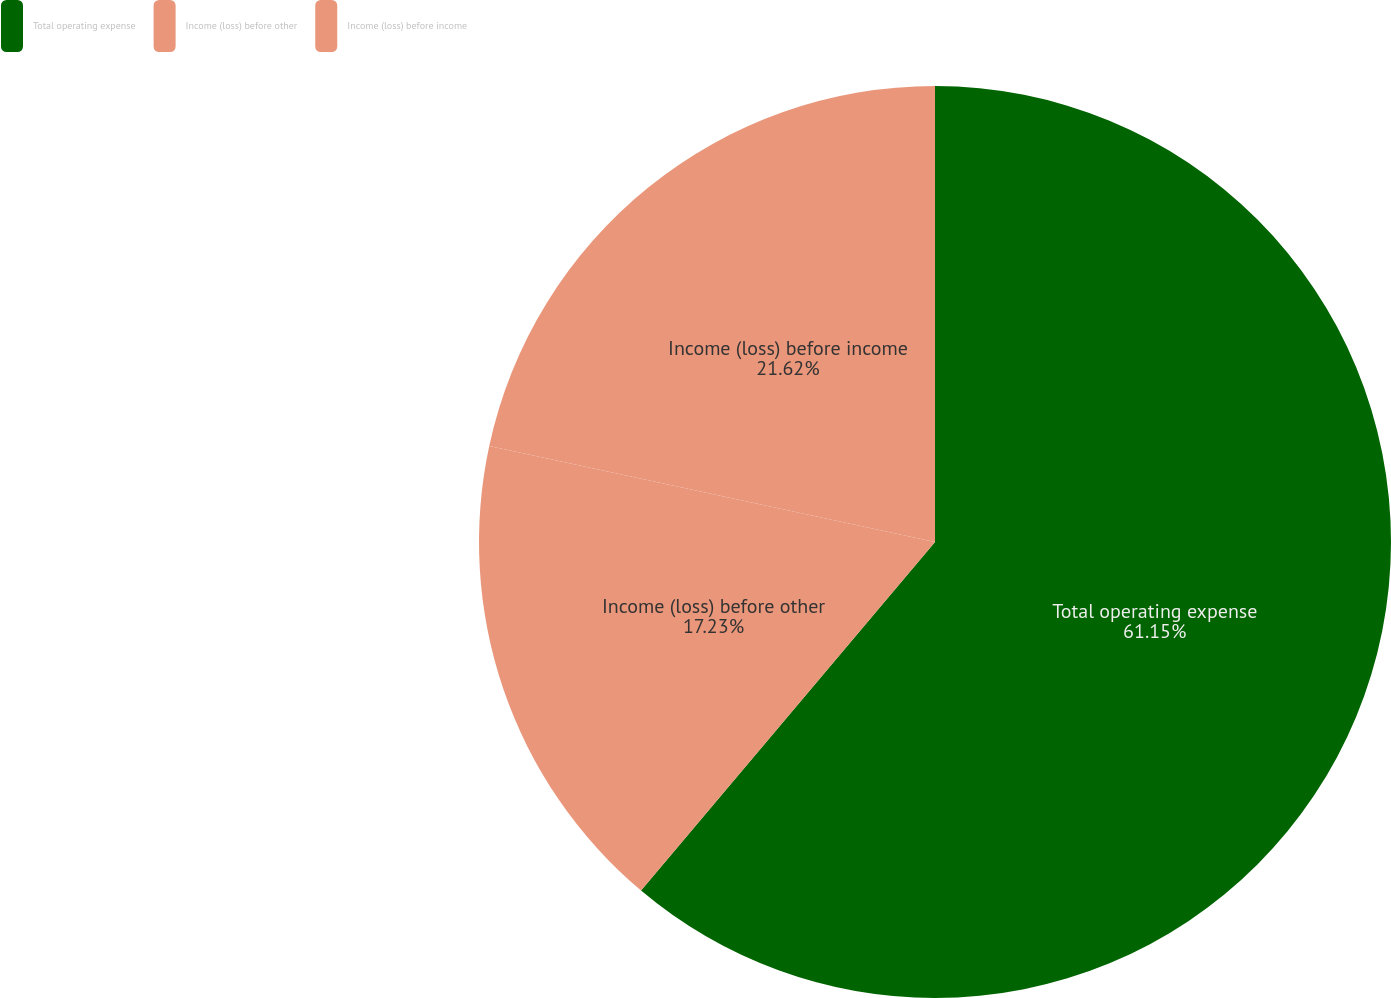Convert chart. <chart><loc_0><loc_0><loc_500><loc_500><pie_chart><fcel>Total operating expense<fcel>Income (loss) before other<fcel>Income (loss) before income<nl><fcel>61.15%<fcel>17.23%<fcel>21.62%<nl></chart> 